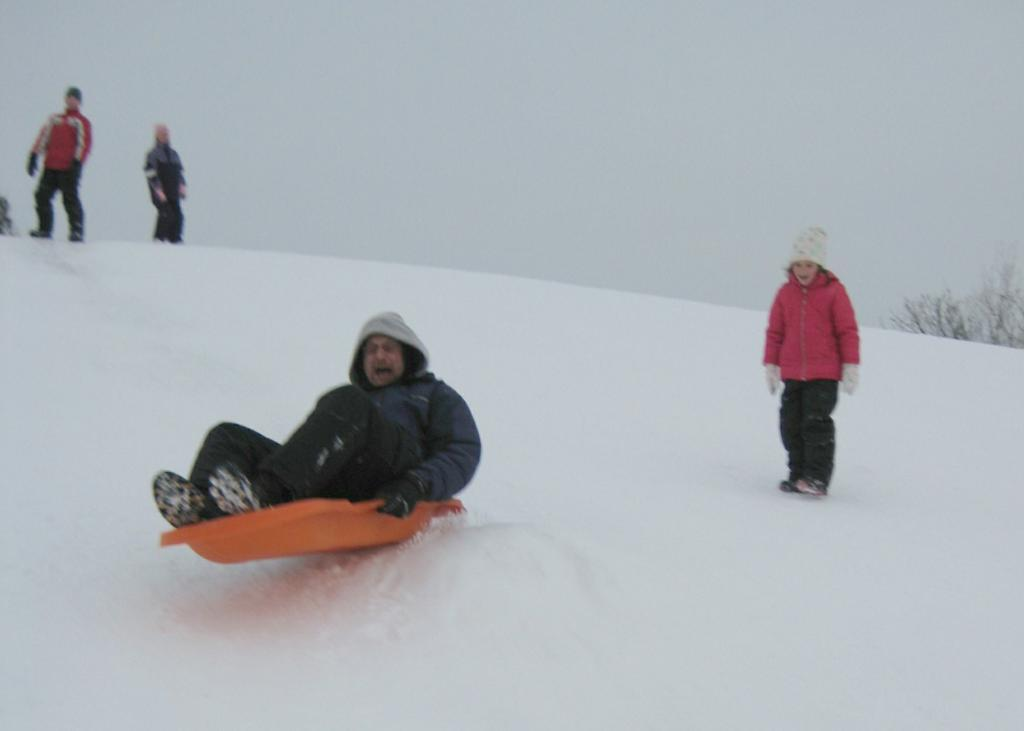What is the person on in the image? There is a person on an object in the image. How many people are standing on snow in the image? There are three people standing on snow in the image. What can be seen in the background of the image? There are trees and fog visible in the background of the image. How many eggs are being held by the person on the object in the image? There are no eggs visible in the image; the person is not holding any eggs. 